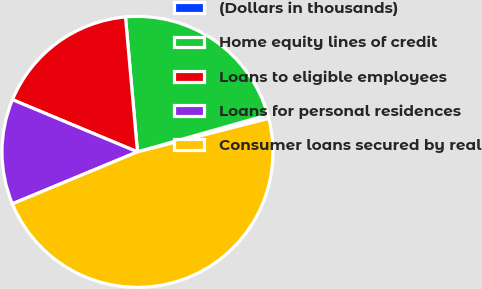<chart> <loc_0><loc_0><loc_500><loc_500><pie_chart><fcel>(Dollars in thousands)<fcel>Home equity lines of credit<fcel>Loans to eligible employees<fcel>Loans for personal residences<fcel>Consumer loans secured by real<nl><fcel>0.43%<fcel>22.01%<fcel>17.29%<fcel>12.56%<fcel>47.71%<nl></chart> 